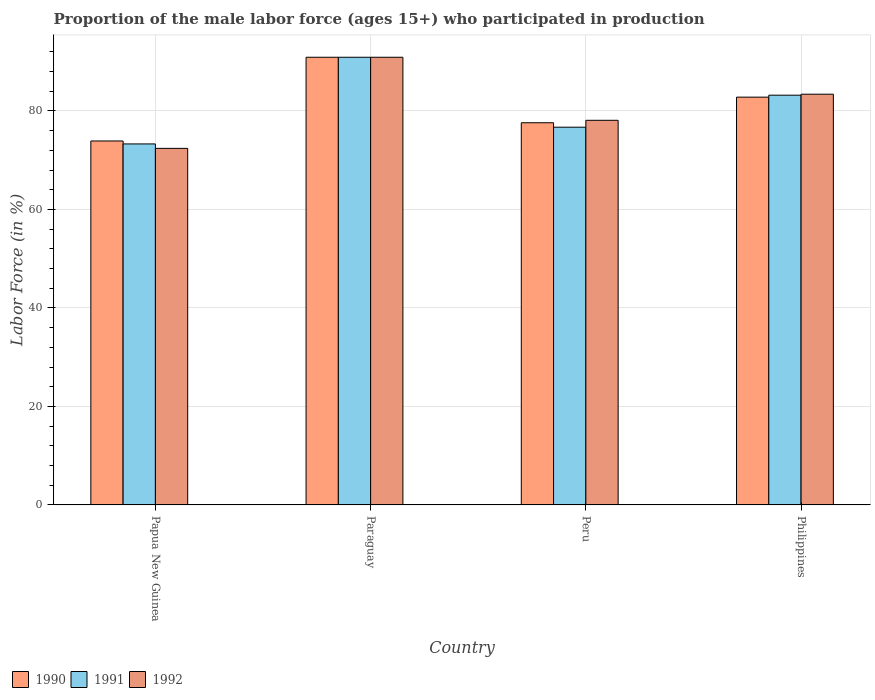How many different coloured bars are there?
Your answer should be very brief. 3. Are the number of bars on each tick of the X-axis equal?
Keep it short and to the point. Yes. How many bars are there on the 3rd tick from the right?
Ensure brevity in your answer.  3. What is the label of the 1st group of bars from the left?
Your response must be concise. Papua New Guinea. What is the proportion of the male labor force who participated in production in 1992 in Papua New Guinea?
Your answer should be compact. 72.4. Across all countries, what is the maximum proportion of the male labor force who participated in production in 1992?
Your answer should be compact. 90.9. Across all countries, what is the minimum proportion of the male labor force who participated in production in 1990?
Offer a very short reply. 73.9. In which country was the proportion of the male labor force who participated in production in 1991 maximum?
Your answer should be compact. Paraguay. In which country was the proportion of the male labor force who participated in production in 1990 minimum?
Offer a terse response. Papua New Guinea. What is the total proportion of the male labor force who participated in production in 1991 in the graph?
Your response must be concise. 324.1. What is the difference between the proportion of the male labor force who participated in production in 1990 in Papua New Guinea and the proportion of the male labor force who participated in production in 1992 in Peru?
Your answer should be compact. -4.2. What is the average proportion of the male labor force who participated in production in 1992 per country?
Provide a short and direct response. 81.2. What is the difference between the proportion of the male labor force who participated in production of/in 1990 and proportion of the male labor force who participated in production of/in 1991 in Paraguay?
Offer a very short reply. 0. In how many countries, is the proportion of the male labor force who participated in production in 1992 greater than 72 %?
Make the answer very short. 4. What is the ratio of the proportion of the male labor force who participated in production in 1990 in Paraguay to that in Philippines?
Offer a terse response. 1.1. Is the proportion of the male labor force who participated in production in 1991 in Papua New Guinea less than that in Philippines?
Offer a terse response. Yes. Is the difference between the proportion of the male labor force who participated in production in 1990 in Papua New Guinea and Peru greater than the difference between the proportion of the male labor force who participated in production in 1991 in Papua New Guinea and Peru?
Offer a very short reply. No. What is the difference between the highest and the second highest proportion of the male labor force who participated in production in 1991?
Your response must be concise. 7.7. What is the difference between the highest and the lowest proportion of the male labor force who participated in production in 1991?
Your answer should be very brief. 17.6. Is the sum of the proportion of the male labor force who participated in production in 1992 in Paraguay and Peru greater than the maximum proportion of the male labor force who participated in production in 1991 across all countries?
Give a very brief answer. Yes. What does the 1st bar from the left in Peru represents?
Provide a short and direct response. 1990. What does the 1st bar from the right in Philippines represents?
Make the answer very short. 1992. Is it the case that in every country, the sum of the proportion of the male labor force who participated in production in 1990 and proportion of the male labor force who participated in production in 1992 is greater than the proportion of the male labor force who participated in production in 1991?
Your answer should be compact. Yes. How many bars are there?
Make the answer very short. 12. Are all the bars in the graph horizontal?
Your response must be concise. No. How many countries are there in the graph?
Your response must be concise. 4. What is the difference between two consecutive major ticks on the Y-axis?
Make the answer very short. 20. Does the graph contain grids?
Provide a short and direct response. Yes. What is the title of the graph?
Make the answer very short. Proportion of the male labor force (ages 15+) who participated in production. What is the label or title of the X-axis?
Provide a succinct answer. Country. What is the Labor Force (in %) in 1990 in Papua New Guinea?
Provide a succinct answer. 73.9. What is the Labor Force (in %) of 1991 in Papua New Guinea?
Provide a succinct answer. 73.3. What is the Labor Force (in %) in 1992 in Papua New Guinea?
Your answer should be compact. 72.4. What is the Labor Force (in %) of 1990 in Paraguay?
Ensure brevity in your answer.  90.9. What is the Labor Force (in %) of 1991 in Paraguay?
Your response must be concise. 90.9. What is the Labor Force (in %) in 1992 in Paraguay?
Your answer should be very brief. 90.9. What is the Labor Force (in %) of 1990 in Peru?
Your answer should be compact. 77.6. What is the Labor Force (in %) of 1991 in Peru?
Provide a short and direct response. 76.7. What is the Labor Force (in %) of 1992 in Peru?
Keep it short and to the point. 78.1. What is the Labor Force (in %) in 1990 in Philippines?
Offer a very short reply. 82.8. What is the Labor Force (in %) of 1991 in Philippines?
Ensure brevity in your answer.  83.2. What is the Labor Force (in %) of 1992 in Philippines?
Provide a succinct answer. 83.4. Across all countries, what is the maximum Labor Force (in %) in 1990?
Your answer should be very brief. 90.9. Across all countries, what is the maximum Labor Force (in %) of 1991?
Keep it short and to the point. 90.9. Across all countries, what is the maximum Labor Force (in %) of 1992?
Provide a short and direct response. 90.9. Across all countries, what is the minimum Labor Force (in %) of 1990?
Provide a succinct answer. 73.9. Across all countries, what is the minimum Labor Force (in %) of 1991?
Make the answer very short. 73.3. Across all countries, what is the minimum Labor Force (in %) in 1992?
Provide a succinct answer. 72.4. What is the total Labor Force (in %) of 1990 in the graph?
Your answer should be compact. 325.2. What is the total Labor Force (in %) of 1991 in the graph?
Your answer should be compact. 324.1. What is the total Labor Force (in %) of 1992 in the graph?
Your response must be concise. 324.8. What is the difference between the Labor Force (in %) in 1991 in Papua New Guinea and that in Paraguay?
Your response must be concise. -17.6. What is the difference between the Labor Force (in %) of 1992 in Papua New Guinea and that in Paraguay?
Make the answer very short. -18.5. What is the difference between the Labor Force (in %) of 1991 in Papua New Guinea and that in Peru?
Give a very brief answer. -3.4. What is the difference between the Labor Force (in %) of 1992 in Papua New Guinea and that in Philippines?
Your answer should be compact. -11. What is the difference between the Labor Force (in %) of 1990 in Paraguay and that in Peru?
Keep it short and to the point. 13.3. What is the difference between the Labor Force (in %) of 1992 in Paraguay and that in Peru?
Ensure brevity in your answer.  12.8. What is the difference between the Labor Force (in %) in 1990 in Paraguay and that in Philippines?
Offer a very short reply. 8.1. What is the difference between the Labor Force (in %) of 1992 in Paraguay and that in Philippines?
Keep it short and to the point. 7.5. What is the difference between the Labor Force (in %) of 1990 in Peru and that in Philippines?
Provide a short and direct response. -5.2. What is the difference between the Labor Force (in %) of 1990 in Papua New Guinea and the Labor Force (in %) of 1991 in Paraguay?
Your answer should be very brief. -17. What is the difference between the Labor Force (in %) of 1991 in Papua New Guinea and the Labor Force (in %) of 1992 in Paraguay?
Provide a succinct answer. -17.6. What is the difference between the Labor Force (in %) in 1990 in Papua New Guinea and the Labor Force (in %) in 1992 in Peru?
Provide a short and direct response. -4.2. What is the difference between the Labor Force (in %) in 1991 in Papua New Guinea and the Labor Force (in %) in 1992 in Peru?
Your answer should be very brief. -4.8. What is the difference between the Labor Force (in %) in 1990 in Papua New Guinea and the Labor Force (in %) in 1992 in Philippines?
Make the answer very short. -9.5. What is the difference between the Labor Force (in %) in 1990 in Paraguay and the Labor Force (in %) in 1991 in Peru?
Offer a terse response. 14.2. What is the difference between the Labor Force (in %) in 1990 in Paraguay and the Labor Force (in %) in 1991 in Philippines?
Your answer should be very brief. 7.7. What is the difference between the Labor Force (in %) of 1990 in Paraguay and the Labor Force (in %) of 1992 in Philippines?
Keep it short and to the point. 7.5. What is the difference between the Labor Force (in %) of 1991 in Paraguay and the Labor Force (in %) of 1992 in Philippines?
Make the answer very short. 7.5. What is the average Labor Force (in %) of 1990 per country?
Provide a short and direct response. 81.3. What is the average Labor Force (in %) of 1991 per country?
Provide a succinct answer. 81.03. What is the average Labor Force (in %) of 1992 per country?
Your answer should be very brief. 81.2. What is the difference between the Labor Force (in %) of 1990 and Labor Force (in %) of 1991 in Papua New Guinea?
Your answer should be compact. 0.6. What is the difference between the Labor Force (in %) of 1990 and Labor Force (in %) of 1992 in Paraguay?
Provide a short and direct response. 0. What is the difference between the Labor Force (in %) in 1991 and Labor Force (in %) in 1992 in Paraguay?
Your answer should be compact. 0. What is the difference between the Labor Force (in %) in 1990 and Labor Force (in %) in 1991 in Peru?
Offer a terse response. 0.9. What is the difference between the Labor Force (in %) in 1990 and Labor Force (in %) in 1991 in Philippines?
Ensure brevity in your answer.  -0.4. What is the difference between the Labor Force (in %) of 1990 and Labor Force (in %) of 1992 in Philippines?
Keep it short and to the point. -0.6. What is the difference between the Labor Force (in %) in 1991 and Labor Force (in %) in 1992 in Philippines?
Provide a succinct answer. -0.2. What is the ratio of the Labor Force (in %) of 1990 in Papua New Guinea to that in Paraguay?
Provide a short and direct response. 0.81. What is the ratio of the Labor Force (in %) of 1991 in Papua New Guinea to that in Paraguay?
Keep it short and to the point. 0.81. What is the ratio of the Labor Force (in %) of 1992 in Papua New Guinea to that in Paraguay?
Offer a terse response. 0.8. What is the ratio of the Labor Force (in %) in 1990 in Papua New Guinea to that in Peru?
Give a very brief answer. 0.95. What is the ratio of the Labor Force (in %) of 1991 in Papua New Guinea to that in Peru?
Provide a succinct answer. 0.96. What is the ratio of the Labor Force (in %) in 1992 in Papua New Guinea to that in Peru?
Offer a terse response. 0.93. What is the ratio of the Labor Force (in %) in 1990 in Papua New Guinea to that in Philippines?
Give a very brief answer. 0.89. What is the ratio of the Labor Force (in %) of 1991 in Papua New Guinea to that in Philippines?
Ensure brevity in your answer.  0.88. What is the ratio of the Labor Force (in %) in 1992 in Papua New Guinea to that in Philippines?
Your response must be concise. 0.87. What is the ratio of the Labor Force (in %) of 1990 in Paraguay to that in Peru?
Make the answer very short. 1.17. What is the ratio of the Labor Force (in %) of 1991 in Paraguay to that in Peru?
Make the answer very short. 1.19. What is the ratio of the Labor Force (in %) of 1992 in Paraguay to that in Peru?
Give a very brief answer. 1.16. What is the ratio of the Labor Force (in %) in 1990 in Paraguay to that in Philippines?
Provide a short and direct response. 1.1. What is the ratio of the Labor Force (in %) in 1991 in Paraguay to that in Philippines?
Offer a very short reply. 1.09. What is the ratio of the Labor Force (in %) of 1992 in Paraguay to that in Philippines?
Provide a succinct answer. 1.09. What is the ratio of the Labor Force (in %) in 1990 in Peru to that in Philippines?
Provide a succinct answer. 0.94. What is the ratio of the Labor Force (in %) of 1991 in Peru to that in Philippines?
Your answer should be compact. 0.92. What is the ratio of the Labor Force (in %) of 1992 in Peru to that in Philippines?
Give a very brief answer. 0.94. What is the difference between the highest and the second highest Labor Force (in %) of 1991?
Your answer should be very brief. 7.7. What is the difference between the highest and the second highest Labor Force (in %) of 1992?
Make the answer very short. 7.5. What is the difference between the highest and the lowest Labor Force (in %) in 1990?
Keep it short and to the point. 17. What is the difference between the highest and the lowest Labor Force (in %) in 1991?
Keep it short and to the point. 17.6. 